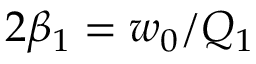<formula> <loc_0><loc_0><loc_500><loc_500>2 \beta _ { 1 } = w _ { 0 } / Q _ { 1 }</formula> 